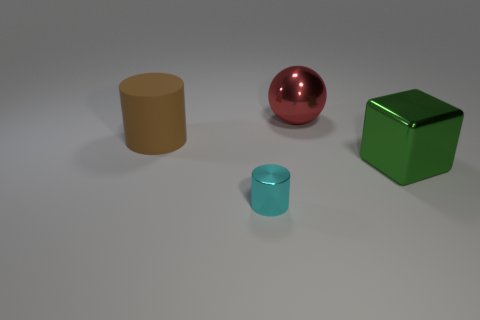What number of shiny things are both in front of the big brown cylinder and behind the cyan metallic thing?
Offer a very short reply. 1. What shape is the metallic thing that is in front of the cube?
Make the answer very short. Cylinder. What number of cylinders have the same size as the brown rubber thing?
Your answer should be compact. 0. What material is the object that is both in front of the brown matte cylinder and behind the small cyan shiny cylinder?
Your answer should be compact. Metal. Is the number of green metal objects greater than the number of large shiny objects?
Give a very brief answer. No. The ball that is behind the cylinder behind the shiny object to the right of the big red object is what color?
Offer a very short reply. Red. Is the material of the big object behind the big brown rubber object the same as the large brown thing?
Ensure brevity in your answer.  No. Are there any tiny yellow cylinders?
Give a very brief answer. No. Do the thing to the right of the red metallic thing and the tiny cyan thing have the same size?
Your answer should be compact. No. Is the number of large red rubber cubes less than the number of large things?
Offer a very short reply. Yes. 